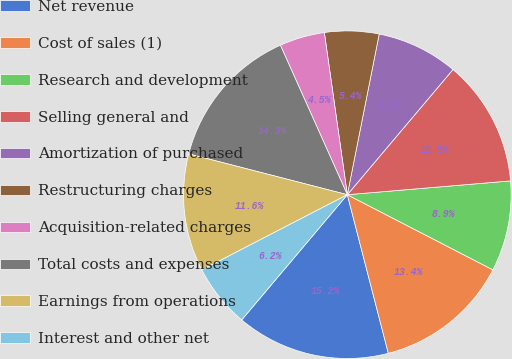Convert chart. <chart><loc_0><loc_0><loc_500><loc_500><pie_chart><fcel>Net revenue<fcel>Cost of sales (1)<fcel>Research and development<fcel>Selling general and<fcel>Amortization of purchased<fcel>Restructuring charges<fcel>Acquisition-related charges<fcel>Total costs and expenses<fcel>Earnings from operations<fcel>Interest and other net<nl><fcel>15.18%<fcel>13.39%<fcel>8.93%<fcel>12.5%<fcel>8.04%<fcel>5.36%<fcel>4.46%<fcel>14.29%<fcel>11.61%<fcel>6.25%<nl></chart> 